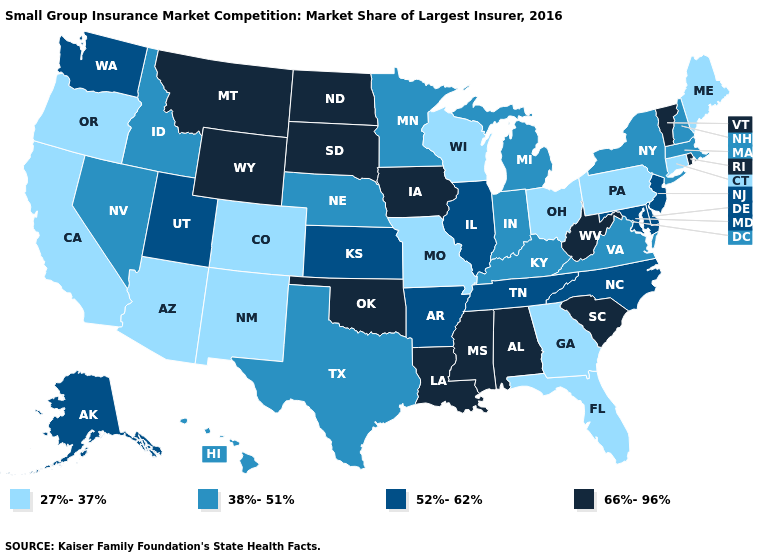What is the value of North Carolina?
Give a very brief answer. 52%-62%. Name the states that have a value in the range 52%-62%?
Answer briefly. Alaska, Arkansas, Delaware, Illinois, Kansas, Maryland, New Jersey, North Carolina, Tennessee, Utah, Washington. Name the states that have a value in the range 52%-62%?
Quick response, please. Alaska, Arkansas, Delaware, Illinois, Kansas, Maryland, New Jersey, North Carolina, Tennessee, Utah, Washington. Among the states that border New Mexico , does Utah have the lowest value?
Be succinct. No. What is the value of Ohio?
Answer briefly. 27%-37%. Name the states that have a value in the range 27%-37%?
Quick response, please. Arizona, California, Colorado, Connecticut, Florida, Georgia, Maine, Missouri, New Mexico, Ohio, Oregon, Pennsylvania, Wisconsin. How many symbols are there in the legend?
Write a very short answer. 4. Which states have the lowest value in the Northeast?
Keep it brief. Connecticut, Maine, Pennsylvania. What is the highest value in states that border Maryland?
Give a very brief answer. 66%-96%. Among the states that border Nevada , does Utah have the highest value?
Give a very brief answer. Yes. Does Iowa have the highest value in the MidWest?
Be succinct. Yes. Does North Dakota have the highest value in the USA?
Give a very brief answer. Yes. What is the value of Maryland?
Short answer required. 52%-62%. What is the lowest value in the Northeast?
Keep it brief. 27%-37%. What is the value of Missouri?
Concise answer only. 27%-37%. 